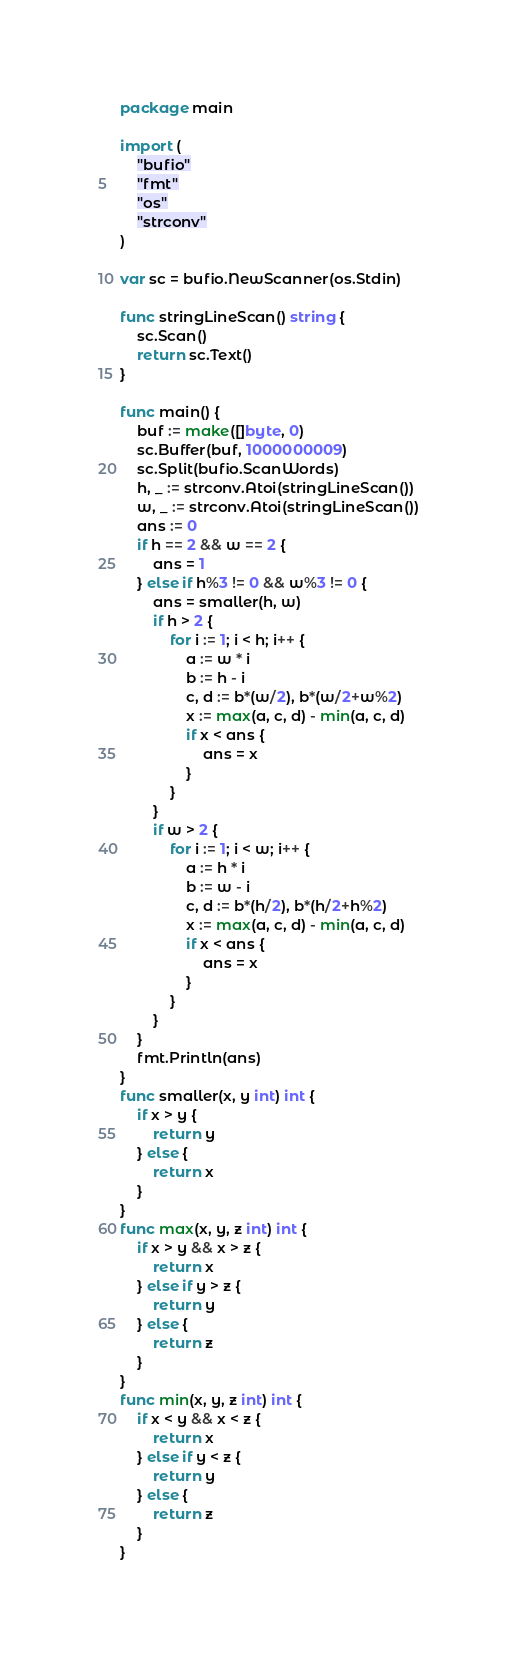<code> <loc_0><loc_0><loc_500><loc_500><_Go_>package main

import (
	"bufio"
	"fmt"
	"os"
	"strconv"
)

var sc = bufio.NewScanner(os.Stdin)

func stringLineScan() string {
	sc.Scan()
	return sc.Text()
}

func main() {
	buf := make([]byte, 0)
	sc.Buffer(buf, 1000000009)
	sc.Split(bufio.ScanWords)
	h, _ := strconv.Atoi(stringLineScan())
	w, _ := strconv.Atoi(stringLineScan())
	ans := 0
	if h == 2 && w == 2 {
		ans = 1
	} else if h%3 != 0 && w%3 != 0 {
		ans = smaller(h, w)
		if h > 2 {
			for i := 1; i < h; i++ {
				a := w * i
				b := h - i
				c, d := b*(w/2), b*(w/2+w%2)
				x := max(a, c, d) - min(a, c, d)
				if x < ans {
					ans = x
				}
			}
		}
		if w > 2 {
			for i := 1; i < w; i++ {
				a := h * i
				b := w - i
				c, d := b*(h/2), b*(h/2+h%2)
				x := max(a, c, d) - min(a, c, d)
				if x < ans {
					ans = x
				}
			}
		}
	}
	fmt.Println(ans)
}
func smaller(x, y int) int {
	if x > y {
		return y
	} else {
		return x
	}
}
func max(x, y, z int) int {
	if x > y && x > z {
		return x
	} else if y > z {
		return y
	} else {
		return z
	}
}
func min(x, y, z int) int {
	if x < y && x < z {
		return x
	} else if y < z {
		return y
	} else {
		return z
	}
}
</code> 